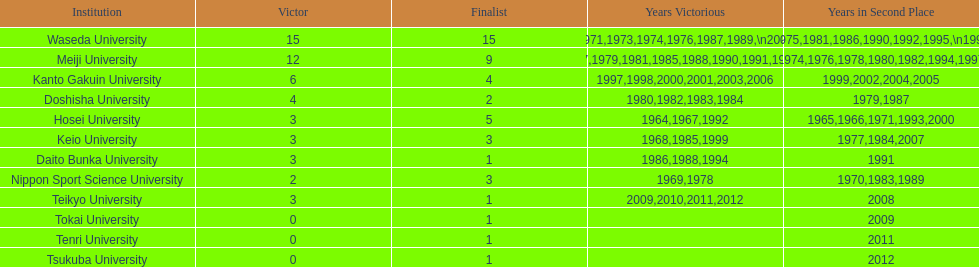Who was the victor in 1965, following hosei's triumph in 1964? Waseda University. 